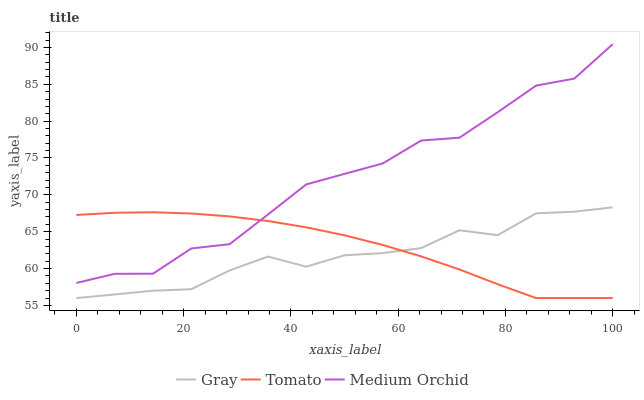Does Gray have the minimum area under the curve?
Answer yes or no. Yes. Does Medium Orchid have the maximum area under the curve?
Answer yes or no. Yes. Does Medium Orchid have the minimum area under the curve?
Answer yes or no. No. Does Gray have the maximum area under the curve?
Answer yes or no. No. Is Tomato the smoothest?
Answer yes or no. Yes. Is Medium Orchid the roughest?
Answer yes or no. Yes. Is Gray the smoothest?
Answer yes or no. No. Is Gray the roughest?
Answer yes or no. No. Does Tomato have the lowest value?
Answer yes or no. Yes. Does Medium Orchid have the lowest value?
Answer yes or no. No. Does Medium Orchid have the highest value?
Answer yes or no. Yes. Does Gray have the highest value?
Answer yes or no. No. Is Gray less than Medium Orchid?
Answer yes or no. Yes. Is Medium Orchid greater than Gray?
Answer yes or no. Yes. Does Gray intersect Tomato?
Answer yes or no. Yes. Is Gray less than Tomato?
Answer yes or no. No. Is Gray greater than Tomato?
Answer yes or no. No. Does Gray intersect Medium Orchid?
Answer yes or no. No. 